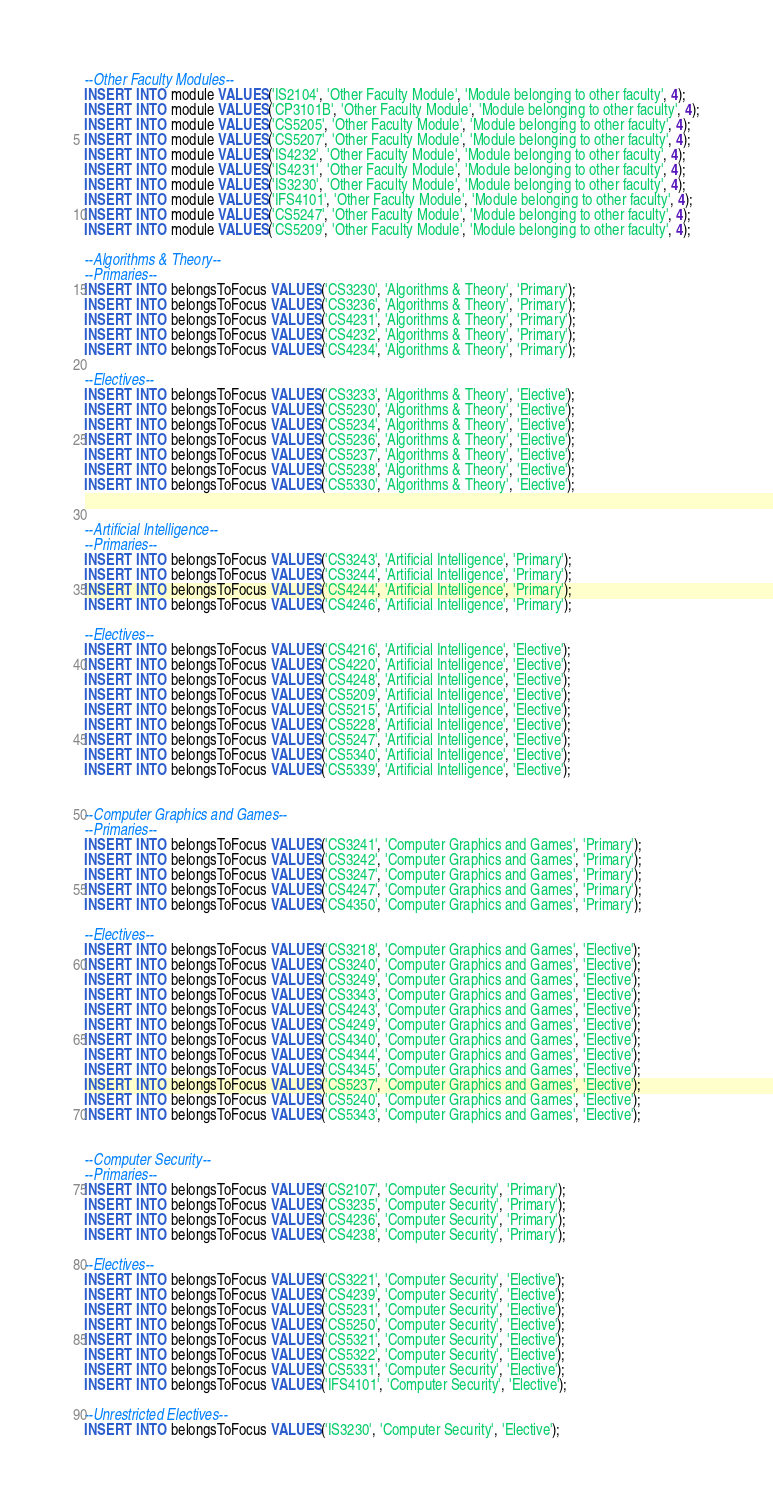Convert code to text. <code><loc_0><loc_0><loc_500><loc_500><_SQL_>--Other Faculty Modules--
INSERT INTO module VALUES('IS2104', 'Other Faculty Module', 'Module belonging to other faculty', 4);
INSERT INTO module VALUES('CP3101B', 'Other Faculty Module', 'Module belonging to other faculty', 4);
INSERT INTO module VALUES('CS5205', 'Other Faculty Module', 'Module belonging to other faculty', 4);
INSERT INTO module VALUES('CS5207', 'Other Faculty Module', 'Module belonging to other faculty', 4);
INSERT INTO module VALUES('IS4232', 'Other Faculty Module', 'Module belonging to other faculty', 4);
INSERT INTO module VALUES('IS4231', 'Other Faculty Module', 'Module belonging to other faculty', 4);
INSERT INTO module VALUES('IS3230', 'Other Faculty Module', 'Module belonging to other faculty', 4);
INSERT INTO module VALUES('IFS4101', 'Other Faculty Module', 'Module belonging to other faculty', 4);
INSERT INTO module VALUES('CS5247', 'Other Faculty Module', 'Module belonging to other faculty', 4);
INSERT INTO module VALUES('CS5209', 'Other Faculty Module', 'Module belonging to other faculty', 4);

--Algorithms & Theory--
--Primaries--
INSERT INTO belongsToFocus VALUES('CS3230', 'Algorithms & Theory', 'Primary');
INSERT INTO belongsToFocus VALUES('CS3236', 'Algorithms & Theory', 'Primary');
INSERT INTO belongsToFocus VALUES('CS4231', 'Algorithms & Theory', 'Primary');
INSERT INTO belongsToFocus VALUES('CS4232', 'Algorithms & Theory', 'Primary');
INSERT INTO belongsToFocus VALUES('CS4234', 'Algorithms & Theory', 'Primary');

--Electives--
INSERT INTO belongsToFocus VALUES('CS3233', 'Algorithms & Theory', 'Elective');
INSERT INTO belongsToFocus VALUES('CS5230', 'Algorithms & Theory', 'Elective');
INSERT INTO belongsToFocus VALUES('CS5234', 'Algorithms & Theory', 'Elective');
INSERT INTO belongsToFocus VALUES('CS5236', 'Algorithms & Theory', 'Elective');
INSERT INTO belongsToFocus VALUES('CS5237', 'Algorithms & Theory', 'Elective');
INSERT INTO belongsToFocus VALUES('CS5238', 'Algorithms & Theory', 'Elective');
INSERT INTO belongsToFocus VALUES('CS5330', 'Algorithms & Theory', 'Elective');


--Artificial Intelligence--
--Primaries--
INSERT INTO belongsToFocus VALUES('CS3243', 'Artificial Intelligence', 'Primary');
INSERT INTO belongsToFocus VALUES('CS3244', 'Artificial Intelligence', 'Primary');
INSERT INTO belongsToFocus VALUES('CS4244', 'Artificial Intelligence', 'Primary');
INSERT INTO belongsToFocus VALUES('CS4246', 'Artificial Intelligence', 'Primary');

--Electives--
INSERT INTO belongsToFocus VALUES('CS4216', 'Artificial Intelligence', 'Elective');
INSERT INTO belongsToFocus VALUES('CS4220', 'Artificial Intelligence', 'Elective');
INSERT INTO belongsToFocus VALUES('CS4248', 'Artificial Intelligence', 'Elective');
INSERT INTO belongsToFocus VALUES('CS5209', 'Artificial Intelligence', 'Elective');
INSERT INTO belongsToFocus VALUES('CS5215', 'Artificial Intelligence', 'Elective');
INSERT INTO belongsToFocus VALUES('CS5228', 'Artificial Intelligence', 'Elective');
INSERT INTO belongsToFocus VALUES('CS5247', 'Artificial Intelligence', 'Elective');
INSERT INTO belongsToFocus VALUES('CS5340', 'Artificial Intelligence', 'Elective');
INSERT INTO belongsToFocus VALUES('CS5339', 'Artificial Intelligence', 'Elective');


--Computer Graphics and Games--
--Primaries--
INSERT INTO belongsToFocus VALUES('CS3241', 'Computer Graphics and Games', 'Primary');
INSERT INTO belongsToFocus VALUES('CS3242', 'Computer Graphics and Games', 'Primary');
INSERT INTO belongsToFocus VALUES('CS3247', 'Computer Graphics and Games', 'Primary');
INSERT INTO belongsToFocus VALUES('CS4247', 'Computer Graphics and Games', 'Primary');
INSERT INTO belongsToFocus VALUES('CS4350', 'Computer Graphics and Games', 'Primary');

--Electives--
INSERT INTO belongsToFocus VALUES('CS3218', 'Computer Graphics and Games', 'Elective');
INSERT INTO belongsToFocus VALUES('CS3240', 'Computer Graphics and Games', 'Elective');
INSERT INTO belongsToFocus VALUES('CS3249', 'Computer Graphics and Games', 'Elective');
INSERT INTO belongsToFocus VALUES('CS3343', 'Computer Graphics and Games', 'Elective');
INSERT INTO belongsToFocus VALUES('CS4243', 'Computer Graphics and Games', 'Elective');
INSERT INTO belongsToFocus VALUES('CS4249', 'Computer Graphics and Games', 'Elective');
INSERT INTO belongsToFocus VALUES('CS4340', 'Computer Graphics and Games', 'Elective');
INSERT INTO belongsToFocus VALUES('CS4344', 'Computer Graphics and Games', 'Elective');
INSERT INTO belongsToFocus VALUES('CS4345', 'Computer Graphics and Games', 'Elective');
INSERT INTO belongsToFocus VALUES('CS5237', 'Computer Graphics and Games', 'Elective');
INSERT INTO belongsToFocus VALUES('CS5240', 'Computer Graphics and Games', 'Elective');
INSERT INTO belongsToFocus VALUES('CS5343', 'Computer Graphics and Games', 'Elective');


--Computer Security--
--Primaries--
INSERT INTO belongsToFocus VALUES('CS2107', 'Computer Security', 'Primary');
INSERT INTO belongsToFocus VALUES('CS3235', 'Computer Security', 'Primary');
INSERT INTO belongsToFocus VALUES('CS4236', 'Computer Security', 'Primary');
INSERT INTO belongsToFocus VALUES('CS4238', 'Computer Security', 'Primary');

--Electives--
INSERT INTO belongsToFocus VALUES('CS3221', 'Computer Security', 'Elective');
INSERT INTO belongsToFocus VALUES('CS4239', 'Computer Security', 'Elective');
INSERT INTO belongsToFocus VALUES('CS5231', 'Computer Security', 'Elective');
INSERT INTO belongsToFocus VALUES('CS5250', 'Computer Security', 'Elective');
INSERT INTO belongsToFocus VALUES('CS5321', 'Computer Security', 'Elective');
INSERT INTO belongsToFocus VALUES('CS5322', 'Computer Security', 'Elective');
INSERT INTO belongsToFocus VALUES('CS5331', 'Computer Security', 'Elective');
INSERT INTO belongsToFocus VALUES('IFS4101', 'Computer Security', 'Elective');

--Unrestricted Electives--
INSERT INTO belongsToFocus VALUES('IS3230', 'Computer Security', 'Elective');</code> 